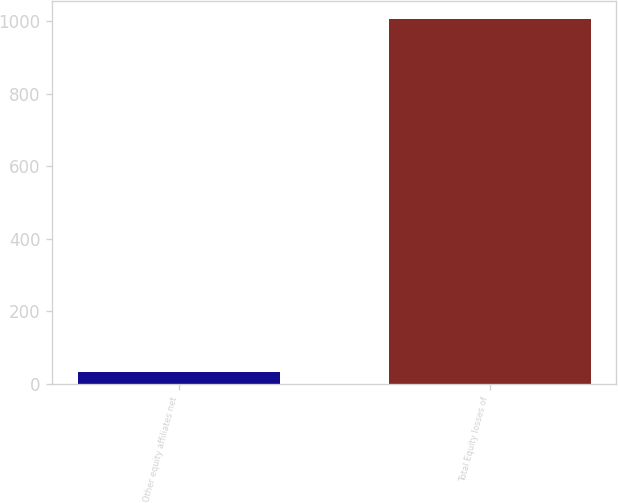<chart> <loc_0><loc_0><loc_500><loc_500><bar_chart><fcel>Other equity affiliates net<fcel>Total Equity losses of<nl><fcel>32<fcel>1006<nl></chart> 